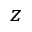Convert formula to latex. <formula><loc_0><loc_0><loc_500><loc_500>z</formula> 